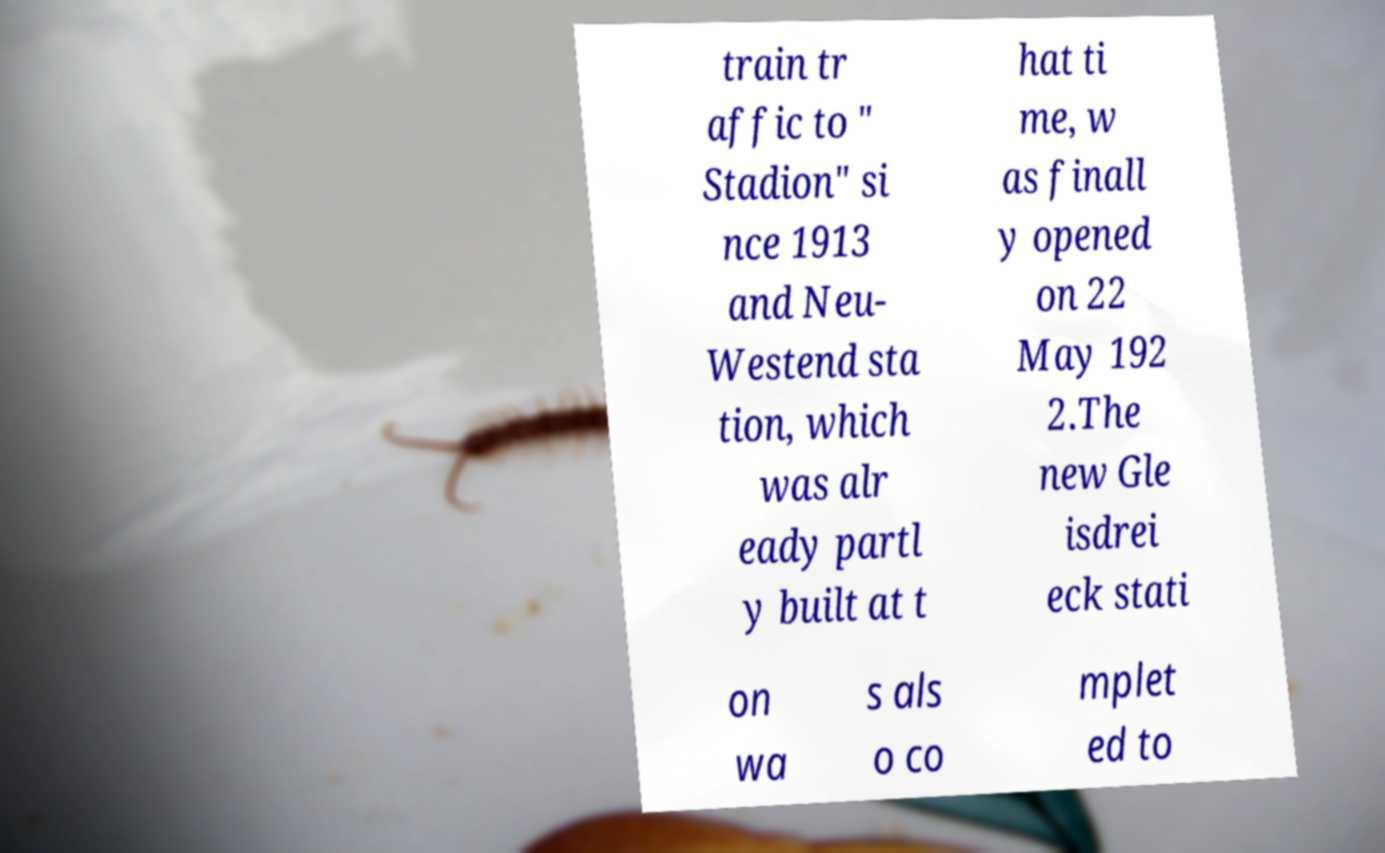There's text embedded in this image that I need extracted. Can you transcribe it verbatim? train tr affic to " Stadion" si nce 1913 and Neu- Westend sta tion, which was alr eady partl y built at t hat ti me, w as finall y opened on 22 May 192 2.The new Gle isdrei eck stati on wa s als o co mplet ed to 